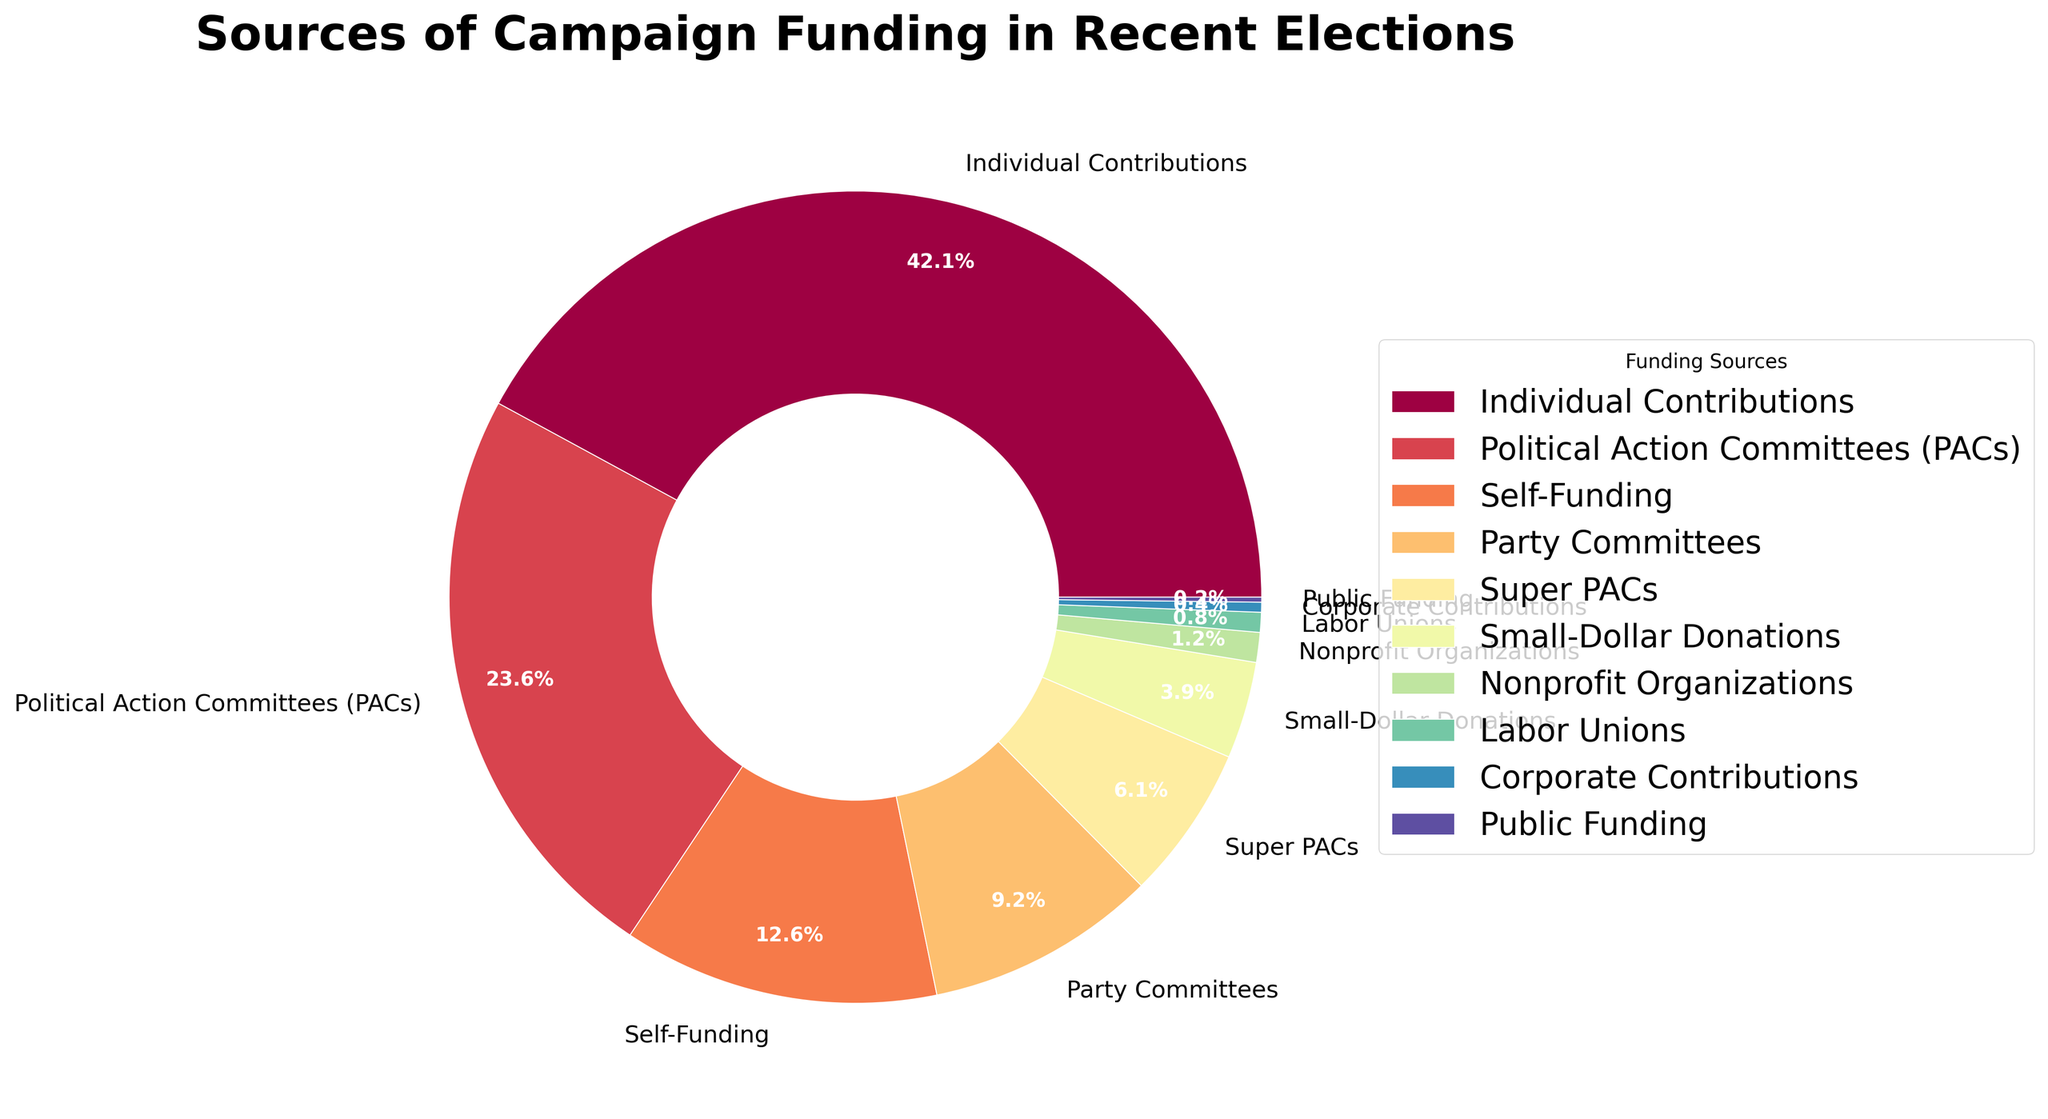What is the largest source of campaign funding? The chart shows different sources of campaign funding with their respective percentages. The largest slice of the pie chart is labeled "Individual Contributions" and accounts for 42.5%, making it the largest source of campaign funding.
Answer: Individual Contributions Which source of campaign funding has the smallest percentage? By examining the pie chart, the smallest slice is labeled "Public Funding" with a percentage of 0.2%, indicating that it is the smallest source of campaign funding.
Answer: Public Funding What is the combined percentage of Political Action Committees (PACs) and Super PACs? To find the combined percentage, add the percentages of both funding sources: PACs (23.8%) and Super PACs (6.2%). The sum is 23.8 + 6.2 = 30%.
Answer: 30% Which source of funding is greater: Self-Funding or Small-Dollar Donations? Compare the percentages of Self-Funding (12.7%) and Small-Dollar Donations (3.9%). Self-Funding has a higher percentage than Small-Dollar Donations.
Answer: Self-Funding How much more is the percentage of Individual Contributions compared to Party Committees? Subtract the percentage of Party Committees (9.3%) from the percentage of Individual Contributions (42.5%). Thus, 42.5 - 9.3 = 33.2%.
Answer: 33.2% Are Nonprofit Organizations' contributions greater than Labor Unions' contributions? Compare the percentages. Nonprofit Organizations have 1.2% and Labor Unions have 0.8%. Nonprofit Organizations contribute more than Labor Unions.
Answer: Yes What's the total percentage represented by Corporate Contributions, Labor Unions, and Public Funding combined? Add the percentages together: Corporate Contributions (0.4%), Labor Unions (0.8%), and Public Funding (0.2%), which gives 0.4 + 0.8 + 0.2 = 1.4%.
Answer: 1.4% Which color on the chart represents Super PACs? Look for the slice labeled "Super PACs" and identify its color. The slice representing Super PACs is a specific shade needed to be observed from the visual information.
Answer: [Color matching the Super PACs segment] What is the difference in percentage between the two smallest sources of campaign funding? First, identify the two smallest sources, which are Public Funding (0.2%) and Corporate Contributions (0.4%). The difference is 0.4 - 0.2 = 0.2%.
Answer: 0.2% Compare the contributions of Self-Funding to the total contributions from Party Committees and Small-Dollar Donations combined. Add the percentages of Party Committees (9.3%) and Small-Dollar Donations (3.9%), then compare to Self-Funding (12.7%). The combined percentage is 9.3 + 3.9 = 13.2%, which is slightly more than Self-Funding.
Answer: 13.2% (combined), 12.7% (Self-Funding) 